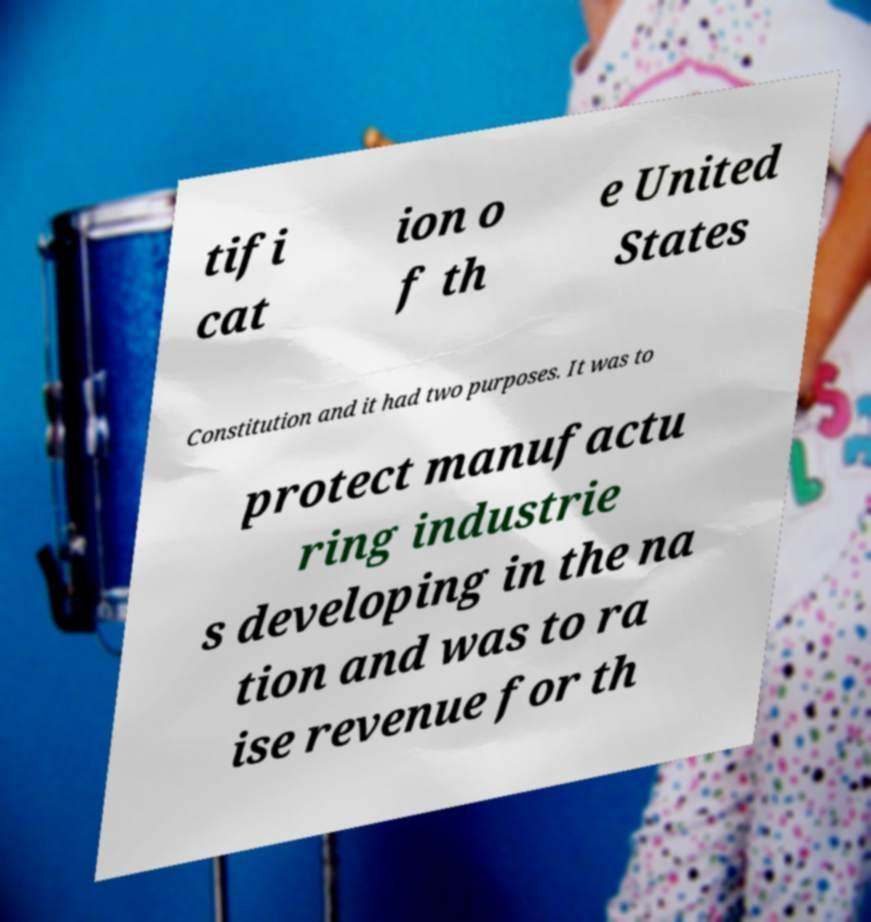Can you accurately transcribe the text from the provided image for me? tifi cat ion o f th e United States Constitution and it had two purposes. It was to protect manufactu ring industrie s developing in the na tion and was to ra ise revenue for th 